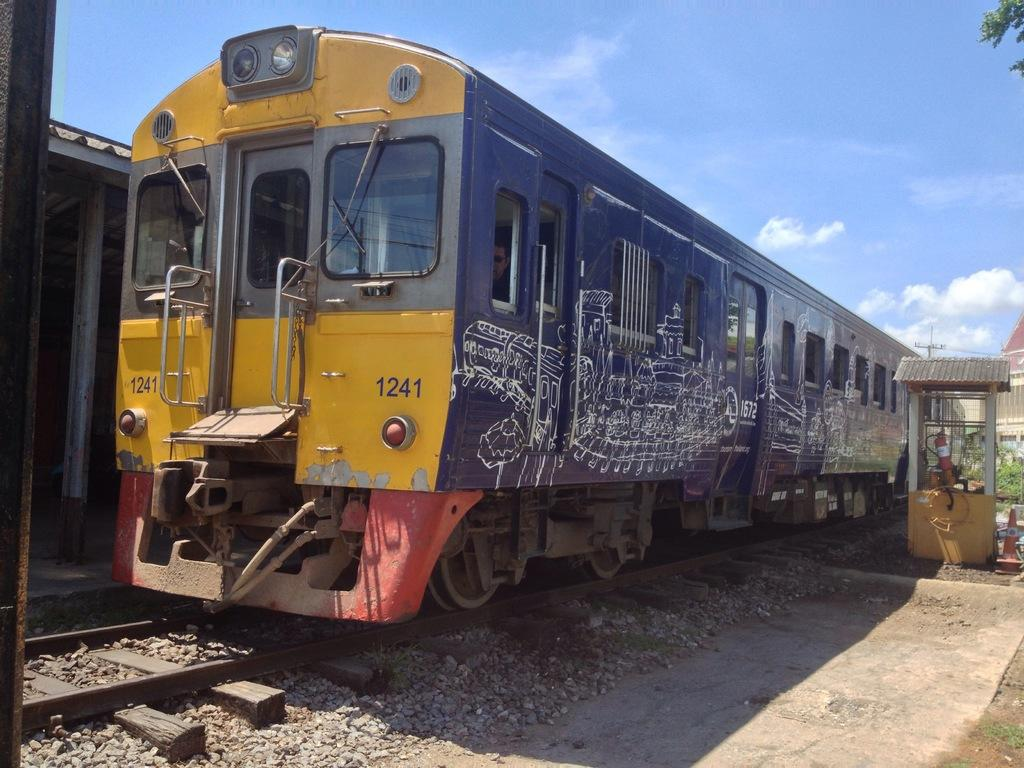What is the main subject in the center of the image? There is a train in the center of the image. What is the train positioned on? The train is on a railway track. What can be seen in the background of the image? There are buildings and the sky visible in the background of the image. What is the condition of the sky in the image? The sky has clouds in it. What type of iron is being used by the father in the image? There is no father or iron present in the image; it features a train on a railway track with buildings and clouds in the background. 